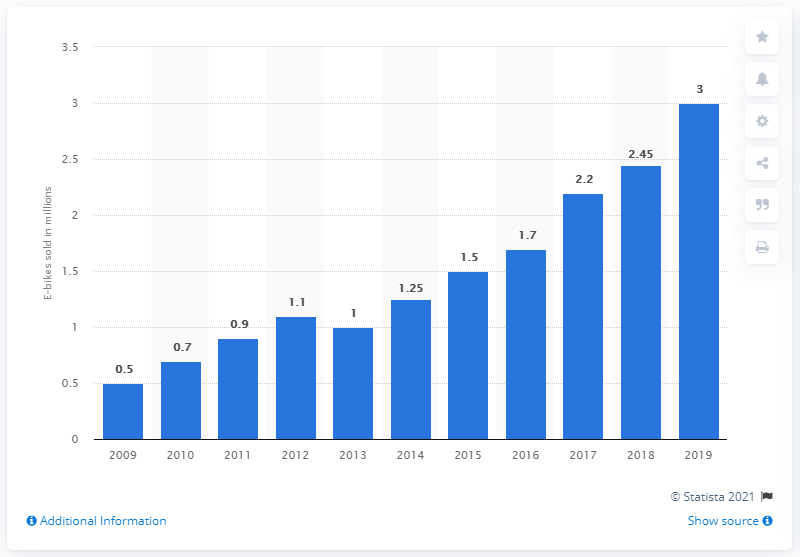Specify some key components in this picture. In 2019, a significant number of e-bikes were sold. 